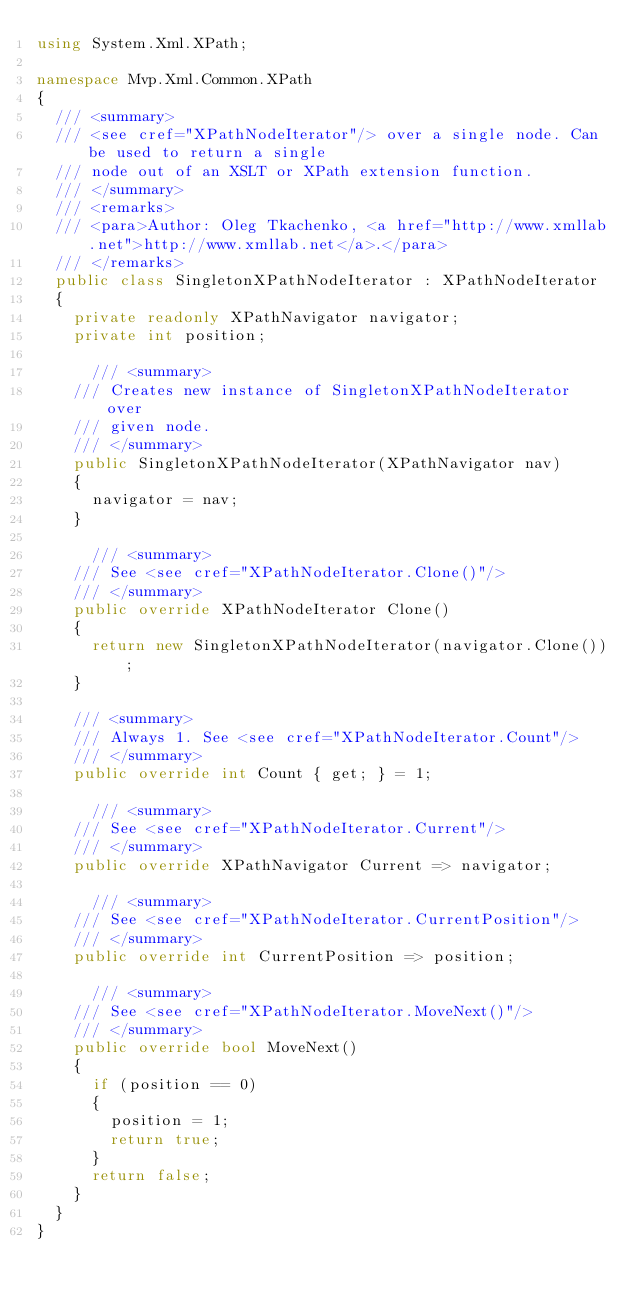<code> <loc_0><loc_0><loc_500><loc_500><_C#_>using System.Xml.XPath;

namespace Mvp.Xml.Common.XPath
{
	/// <summary>
	/// <see cref="XPathNodeIterator"/> over a single node. Can be used to return a single
	/// node out of an XSLT or XPath extension function.
	/// </summary>
	/// <remarks>
	/// <para>Author: Oleg Tkachenko, <a href="http://www.xmllab.net">http://www.xmllab.net</a>.</para>
	/// </remarks>
	public class SingletonXPathNodeIterator : XPathNodeIterator
	{
		private readonly XPathNavigator navigator;
		private int position;

	    /// <summary>
		/// Creates new instance of SingletonXPathNodeIterator over
		/// given node.
		/// </summary>
		public SingletonXPathNodeIterator(XPathNavigator nav)
		{
			navigator = nav;
		}

	    /// <summary>
		/// See <see cref="XPathNodeIterator.Clone()"/>
		/// </summary>
		public override XPathNodeIterator Clone()
		{
			return new SingletonXPathNodeIterator(navigator.Clone());
		}

		/// <summary>
		/// Always 1. See <see cref="XPathNodeIterator.Count"/>
		/// </summary>
		public override int Count { get; } = 1;

	    /// <summary>
		/// See <see cref="XPathNodeIterator.Current"/>
		/// </summary>
		public override XPathNavigator Current => navigator;

	    /// <summary>
		/// See <see cref="XPathNodeIterator.CurrentPosition"/>
		/// </summary>
		public override int CurrentPosition => position;

	    /// <summary>
		/// See <see cref="XPathNodeIterator.MoveNext()"/>
		/// </summary>
		public override bool MoveNext()
		{
			if (position == 0)
			{
				position = 1;
				return true;
			}
			return false;
		}
	}
}
</code> 